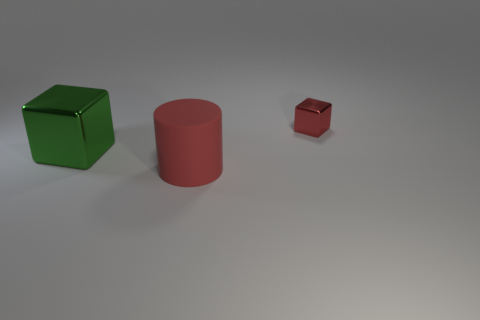Is there any other thing that is the same size as the red cube?
Offer a very short reply. No. Are there an equal number of metal blocks to the left of the red metal block and tiny red spheres?
Make the answer very short. No. There is a shiny object on the left side of the large red matte object; is its size the same as the shiny object that is right of the large shiny block?
Your answer should be very brief. No. How many other objects are the same size as the red matte cylinder?
Give a very brief answer. 1. There is a thing in front of the block left of the tiny red shiny cube; is there a metallic object on the left side of it?
Give a very brief answer. Yes. Are there any other things of the same color as the big shiny thing?
Provide a succinct answer. No. What is the size of the block that is on the right side of the large red object?
Provide a short and direct response. Small. There is a red thing in front of the cube left of the thing that is behind the green metallic cube; what size is it?
Offer a terse response. Large. There is a metal block on the left side of the shiny object to the right of the green block; what color is it?
Give a very brief answer. Green. Is there anything else that is made of the same material as the cylinder?
Provide a succinct answer. No. 